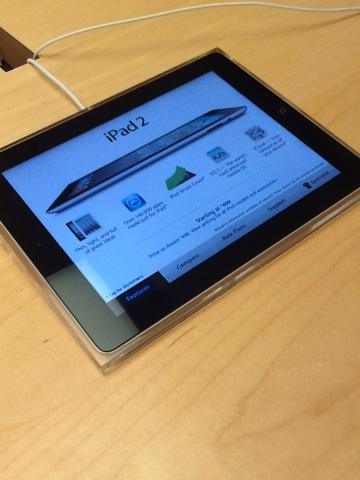Can you tell me more about the features of an iPad 2? Certainly! The iPad 2 includes a 1024x768 pixel resolution display, VGA front-facing and 720p rear-facing cameras. It's capable of up to 10 hours of battery life and offers options for 16, 32, or 64 GB of internal storage. What were some of the major improvements from its predecessor? The iPad 2 was thinner and lighter compared to the original iPad, had improved processing power with its dual-core A5 chip, and featured upgraded cameras, making it more suitable for multimedia tasks. 